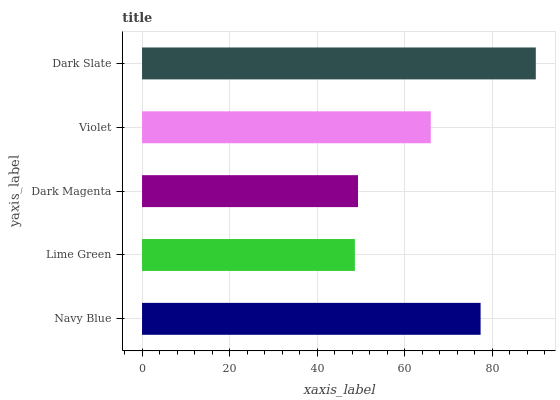Is Lime Green the minimum?
Answer yes or no. Yes. Is Dark Slate the maximum?
Answer yes or no. Yes. Is Dark Magenta the minimum?
Answer yes or no. No. Is Dark Magenta the maximum?
Answer yes or no. No. Is Dark Magenta greater than Lime Green?
Answer yes or no. Yes. Is Lime Green less than Dark Magenta?
Answer yes or no. Yes. Is Lime Green greater than Dark Magenta?
Answer yes or no. No. Is Dark Magenta less than Lime Green?
Answer yes or no. No. Is Violet the high median?
Answer yes or no. Yes. Is Violet the low median?
Answer yes or no. Yes. Is Lime Green the high median?
Answer yes or no. No. Is Navy Blue the low median?
Answer yes or no. No. 